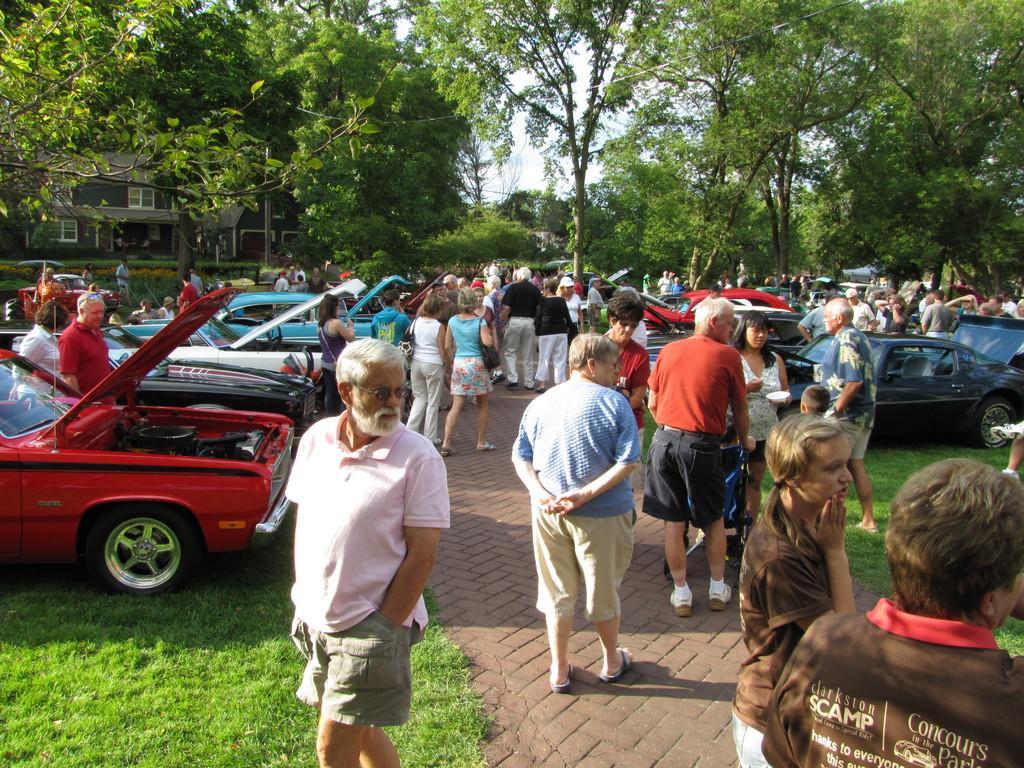Please provide a concise description of this image. In this image I can see many people and also there are many cars at the back, there are many trees and a house and in the background I can see white color. 